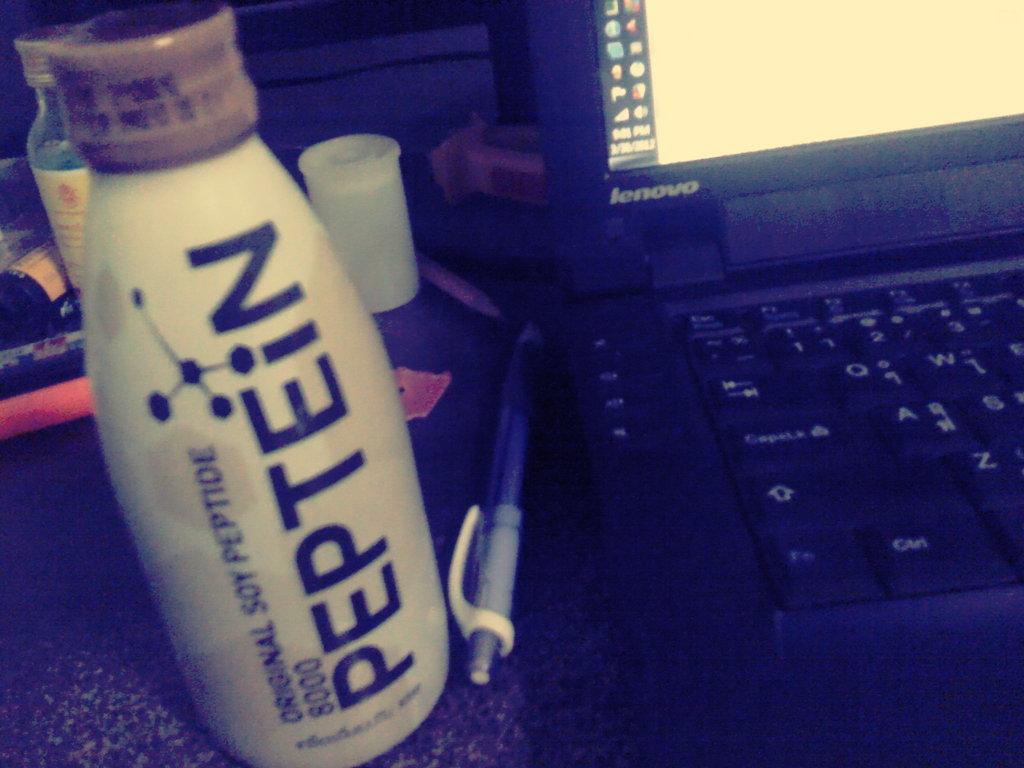What is in the bottle?
Provide a succinct answer. Peptein. What is original about this bottle?
Your answer should be compact. Soy peptide. 